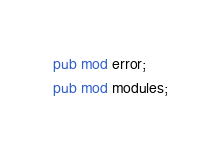Convert code to text. <code><loc_0><loc_0><loc_500><loc_500><_Rust_>pub mod error;
pub mod modules;
</code> 